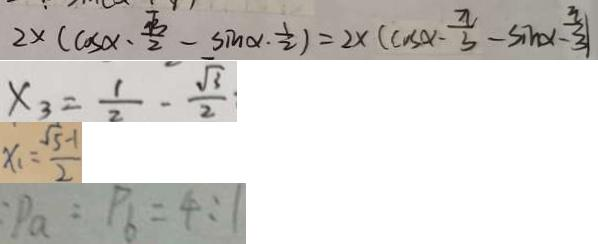Convert formula to latex. <formula><loc_0><loc_0><loc_500><loc_500>2 \times ( \cos x - \frac { \sqrt { 3 } } { 2 } - \sin \alpha \cdot \frac { 1 } { 2 } ) = 2 \times ( \cos \alpha - \frac { \pi } { 3 } - \sin x - \frac { \pi } { 3 } ) 
 x _ { 3 } = \frac { 1 } { 2 } - \frac { \sqrt { 3 } } { 2 } 
 x _ { 1 } = \frac { \sqrt { 5 } - 1 } { 2 } 
 : P _ { a } : P _ { 6 } = 4 : 1</formula> 